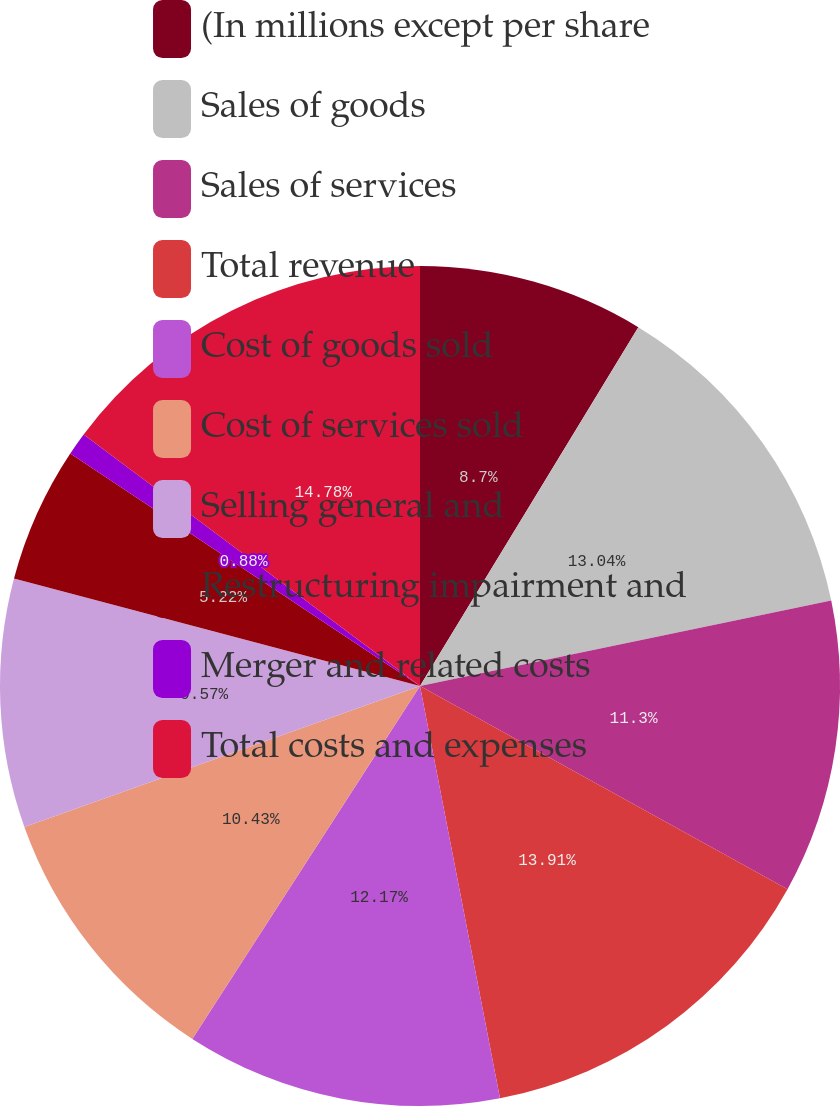Convert chart. <chart><loc_0><loc_0><loc_500><loc_500><pie_chart><fcel>(In millions except per share<fcel>Sales of goods<fcel>Sales of services<fcel>Total revenue<fcel>Cost of goods sold<fcel>Cost of services sold<fcel>Selling general and<fcel>Restructuring impairment and<fcel>Merger and related costs<fcel>Total costs and expenses<nl><fcel>8.7%<fcel>13.04%<fcel>11.3%<fcel>13.91%<fcel>12.17%<fcel>10.43%<fcel>9.57%<fcel>5.22%<fcel>0.88%<fcel>14.78%<nl></chart> 